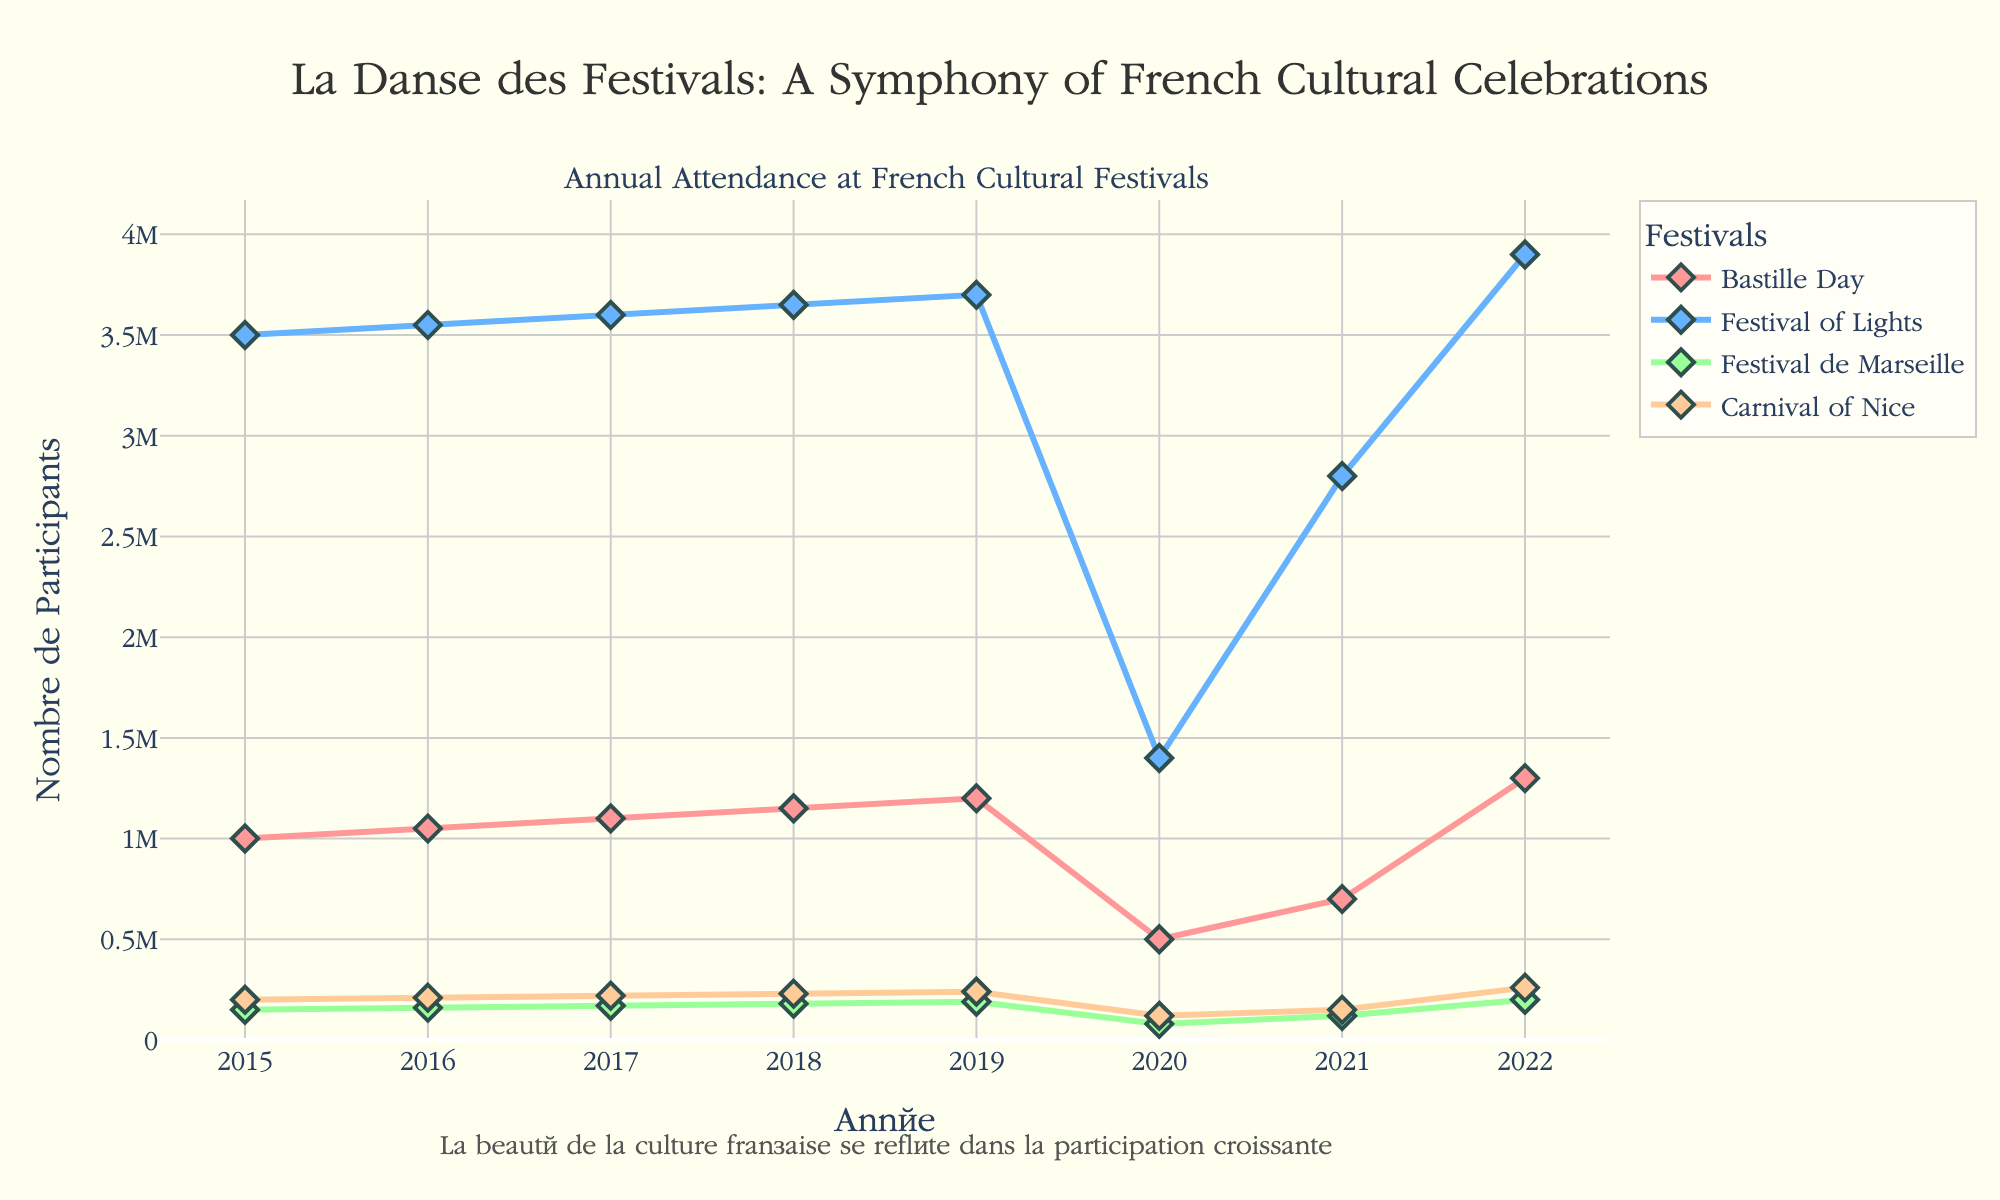What is the title of the figure? The title can be found at the top of the figure. It reads "La Danse des Festivals: A Symphony of French Cultural Celebrations".
Answer: La Danse des Festivals: A Symphony of French Cultural Celebrations Which festival had the highest attendance in 2022? By looking at the y-values for 2022, you can see that "Festival of Lights" in Lyon has the highest attendance.
Answer: Festival of Lights How did the attendance for the 'Bastille Day' festival in Paris change from 2015 to 2020? You look at the y-values corresponding to the 'Bastille Day' in Paris for 2015 and 2020. It decreased from 1,000,000 in 2015 to 500,000 in 2020.
Answer: Decreased Which festival shows a noticeable drop in attendance in 2020 due to global events? Observe the significant declines in attendance values for each festival in 2020. All festivals show a drop, but "Festival of Lights" in Lyon and "Bastille Day" in Paris stand out.
Answer: Festival of Lights and Bastille Day In which year did the attendance for the 'Carnival of Nice' reach its lowest point? Referring to the y-axis values, "Carnival of Nice" reaches its lowest attendance in 2020.
Answer: 2020 What was the attendance for the 'Festival of Lights' in Lyon in 2021? Check the figure for the 'Festival of Lights' plot in 2021, which shows an attendance of 2,800,000.
Answer: 2,800,000 How much did the attendance for the 'Festival de Marseille' in 2017 increase compared to 2016? Look at the attendance values for 'Festival de Marseille' in 2017 (170,000) and 2016 (160,000). The difference can be calculated as 170,000 - 160,000 = 10,000.
Answer: 10,000 Which festival in 2019 had the closest attendance to 2,400,000? Look at the y-axis for 2019 data points and compare the values. "None of the listed festivals" closest to 2,400,000 is the value is under 1,000,000.
Answer: None Did the attendance for the 'Bastille Day' festival in Paris reach over 1,200,000 in any year? Check the 'Bastille Day' data points over the years. In 2022, the value reaches 1,300,000, over 1,200,000.
Answer: Yes Which two festivals had the least variation in attendance from 2015 to 2019? Examine the lines' smoothness for each festival in the given years. 'Carnival of Nice' and 'Festival de Marseille' show the least variation.
Answer: Carnival of Nice and Festival de Marseille 